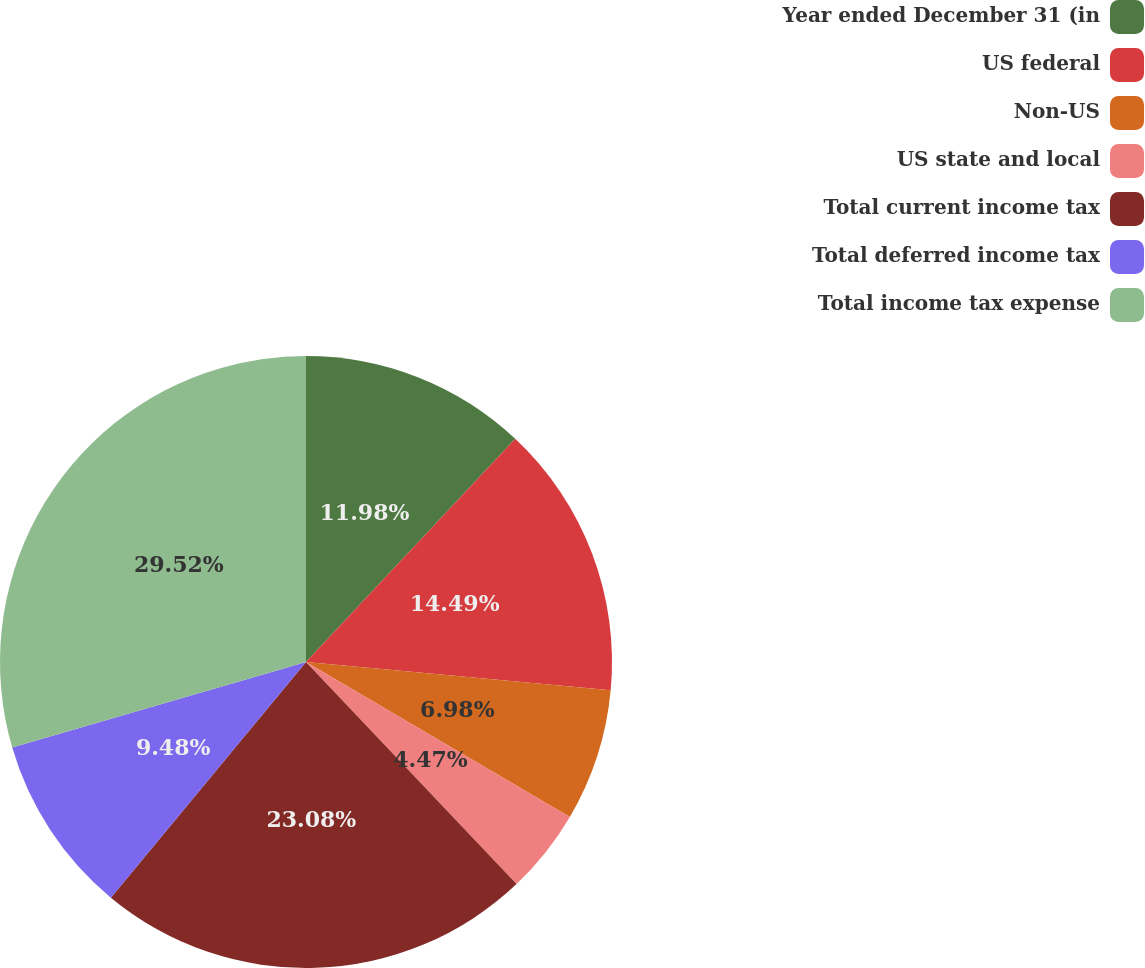Convert chart. <chart><loc_0><loc_0><loc_500><loc_500><pie_chart><fcel>Year ended December 31 (in<fcel>US federal<fcel>Non-US<fcel>US state and local<fcel>Total current income tax<fcel>Total deferred income tax<fcel>Total income tax expense<nl><fcel>11.98%<fcel>14.49%<fcel>6.98%<fcel>4.47%<fcel>23.08%<fcel>9.48%<fcel>29.51%<nl></chart> 